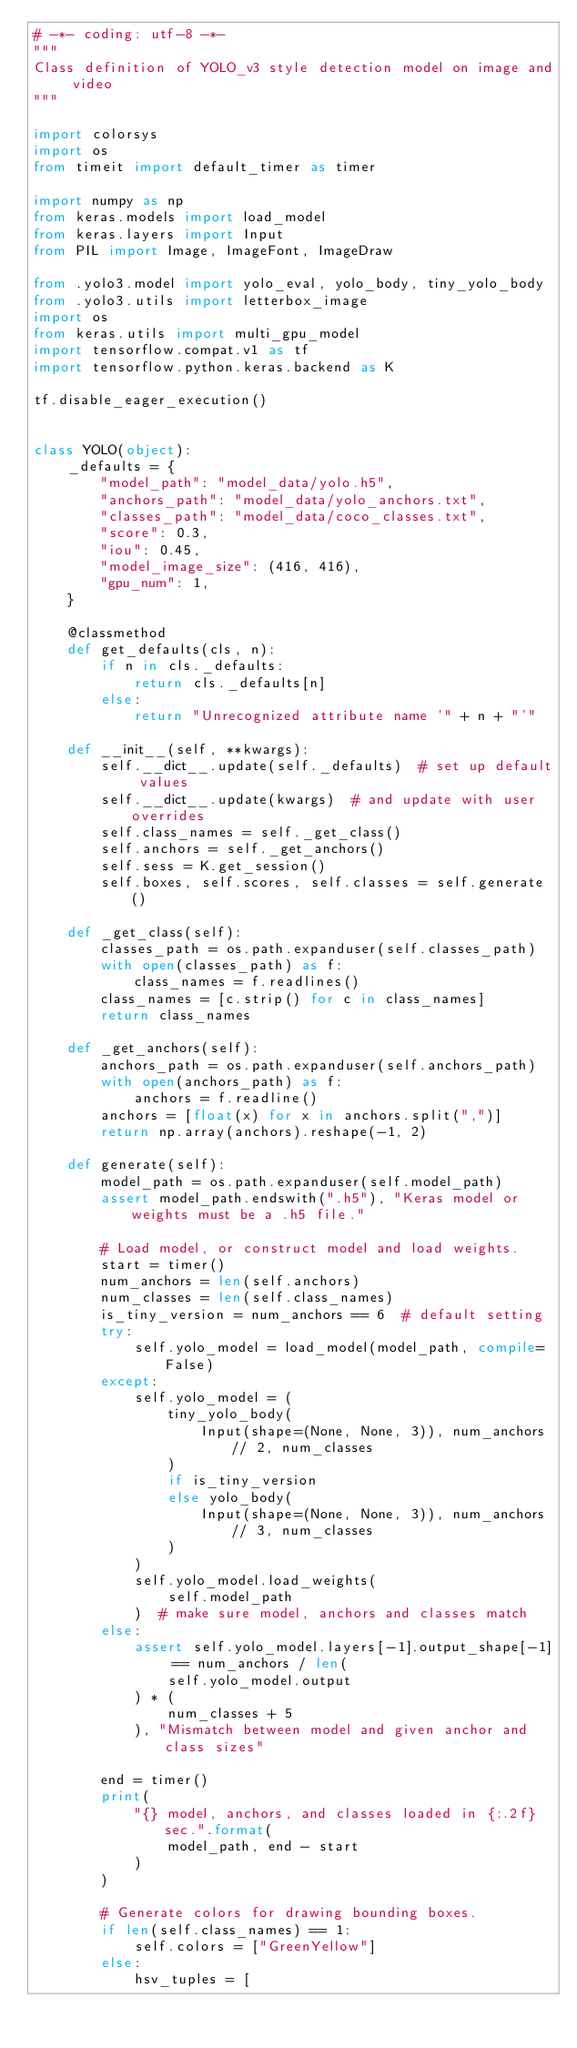<code> <loc_0><loc_0><loc_500><loc_500><_Python_># -*- coding: utf-8 -*-
"""
Class definition of YOLO_v3 style detection model on image and video
"""

import colorsys
import os
from timeit import default_timer as timer

import numpy as np
from keras.models import load_model
from keras.layers import Input
from PIL import Image, ImageFont, ImageDraw

from .yolo3.model import yolo_eval, yolo_body, tiny_yolo_body
from .yolo3.utils import letterbox_image
import os
from keras.utils import multi_gpu_model
import tensorflow.compat.v1 as tf
import tensorflow.python.keras.backend as K

tf.disable_eager_execution()


class YOLO(object):
    _defaults = {
        "model_path": "model_data/yolo.h5",
        "anchors_path": "model_data/yolo_anchors.txt",
        "classes_path": "model_data/coco_classes.txt",
        "score": 0.3,
        "iou": 0.45,
        "model_image_size": (416, 416),
        "gpu_num": 1,
    }

    @classmethod
    def get_defaults(cls, n):
        if n in cls._defaults:
            return cls._defaults[n]
        else:
            return "Unrecognized attribute name '" + n + "'"

    def __init__(self, **kwargs):
        self.__dict__.update(self._defaults)  # set up default values
        self.__dict__.update(kwargs)  # and update with user overrides
        self.class_names = self._get_class()
        self.anchors = self._get_anchors()
        self.sess = K.get_session()
        self.boxes, self.scores, self.classes = self.generate()

    def _get_class(self):
        classes_path = os.path.expanduser(self.classes_path)
        with open(classes_path) as f:
            class_names = f.readlines()
        class_names = [c.strip() for c in class_names]
        return class_names

    def _get_anchors(self):
        anchors_path = os.path.expanduser(self.anchors_path)
        with open(anchors_path) as f:
            anchors = f.readline()
        anchors = [float(x) for x in anchors.split(",")]
        return np.array(anchors).reshape(-1, 2)

    def generate(self):
        model_path = os.path.expanduser(self.model_path)
        assert model_path.endswith(".h5"), "Keras model or weights must be a .h5 file."

        # Load model, or construct model and load weights.
        start = timer()
        num_anchors = len(self.anchors)
        num_classes = len(self.class_names)
        is_tiny_version = num_anchors == 6  # default setting
        try:
            self.yolo_model = load_model(model_path, compile=False)
        except:
            self.yolo_model = (
                tiny_yolo_body(
                    Input(shape=(None, None, 3)), num_anchors // 2, num_classes
                )
                if is_tiny_version
                else yolo_body(
                    Input(shape=(None, None, 3)), num_anchors // 3, num_classes
                )
            )
            self.yolo_model.load_weights(
                self.model_path
            )  # make sure model, anchors and classes match
        else:
            assert self.yolo_model.layers[-1].output_shape[-1] == num_anchors / len(
                self.yolo_model.output
            ) * (
                num_classes + 5
            ), "Mismatch between model and given anchor and class sizes"

        end = timer()
        print(
            "{} model, anchors, and classes loaded in {:.2f}sec.".format(
                model_path, end - start
            )
        )

        # Generate colors for drawing bounding boxes.
        if len(self.class_names) == 1:
            self.colors = ["GreenYellow"]
        else:
            hsv_tuples = [</code> 